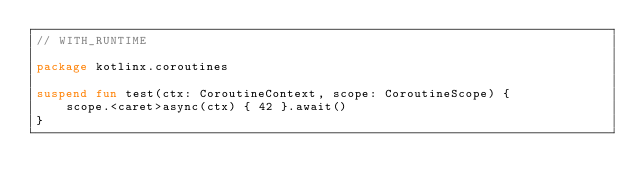<code> <loc_0><loc_0><loc_500><loc_500><_Kotlin_>// WITH_RUNTIME

package kotlinx.coroutines

suspend fun test(ctx: CoroutineContext, scope: CoroutineScope) {
    scope.<caret>async(ctx) { 42 }.await()
}</code> 